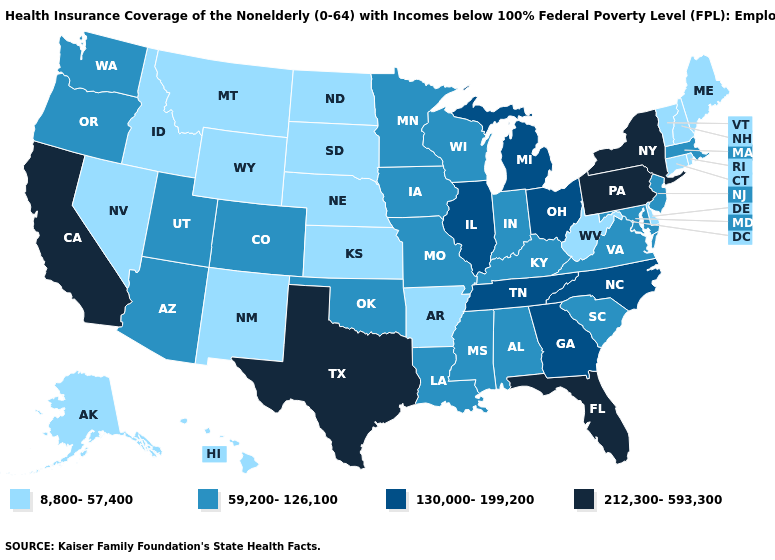How many symbols are there in the legend?
Short answer required. 4. Is the legend a continuous bar?
Be succinct. No. Does Montana have the highest value in the West?
Write a very short answer. No. What is the lowest value in the West?
Answer briefly. 8,800-57,400. Which states have the lowest value in the USA?
Answer briefly. Alaska, Arkansas, Connecticut, Delaware, Hawaii, Idaho, Kansas, Maine, Montana, Nebraska, Nevada, New Hampshire, New Mexico, North Dakota, Rhode Island, South Dakota, Vermont, West Virginia, Wyoming. What is the value of Wyoming?
Write a very short answer. 8,800-57,400. What is the lowest value in the South?
Write a very short answer. 8,800-57,400. Which states have the lowest value in the West?
Write a very short answer. Alaska, Hawaii, Idaho, Montana, Nevada, New Mexico, Wyoming. What is the value of Georgia?
Short answer required. 130,000-199,200. Name the states that have a value in the range 59,200-126,100?
Short answer required. Alabama, Arizona, Colorado, Indiana, Iowa, Kentucky, Louisiana, Maryland, Massachusetts, Minnesota, Mississippi, Missouri, New Jersey, Oklahoma, Oregon, South Carolina, Utah, Virginia, Washington, Wisconsin. Does Maine have the highest value in the USA?
Keep it brief. No. Among the states that border Iowa , which have the highest value?
Short answer required. Illinois. Does the first symbol in the legend represent the smallest category?
Give a very brief answer. Yes. Name the states that have a value in the range 8,800-57,400?
Concise answer only. Alaska, Arkansas, Connecticut, Delaware, Hawaii, Idaho, Kansas, Maine, Montana, Nebraska, Nevada, New Hampshire, New Mexico, North Dakota, Rhode Island, South Dakota, Vermont, West Virginia, Wyoming. Name the states that have a value in the range 212,300-593,300?
Short answer required. California, Florida, New York, Pennsylvania, Texas. 